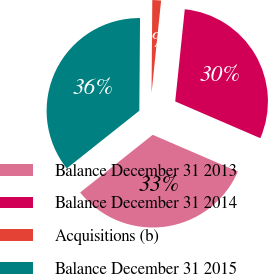Convert chart to OTSL. <chart><loc_0><loc_0><loc_500><loc_500><pie_chart><fcel>Balance December 31 2013<fcel>Balance December 31 2014<fcel>Acquisitions (b)<fcel>Balance December 31 2015<nl><fcel>32.83%<fcel>29.84%<fcel>1.52%<fcel>35.81%<nl></chart> 